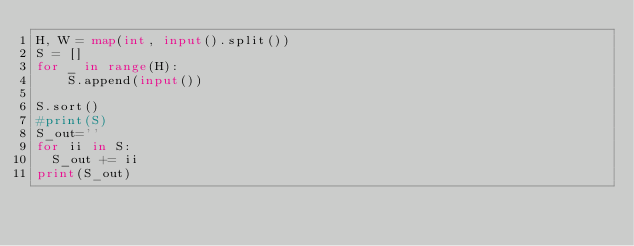<code> <loc_0><loc_0><loc_500><loc_500><_Python_>H, W = map(int, input().split())
S = []
for _ in range(H):
    S.append(input())

S.sort()
#print(S)
S_out=''
for ii in S:
  S_out += ii
print(S_out)
</code> 